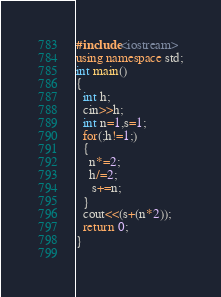<code> <loc_0><loc_0><loc_500><loc_500><_C++_>#include<iostream>
using namespace std;
int main()
{
  int h;
  cin>>h;
  int n=1,s=1;
  for(;h!=1;)
  {
    n*=2;
    h/=2;
     s+=n;
  }
  cout<<(s+(n*2));
  return 0;
}
     </code> 